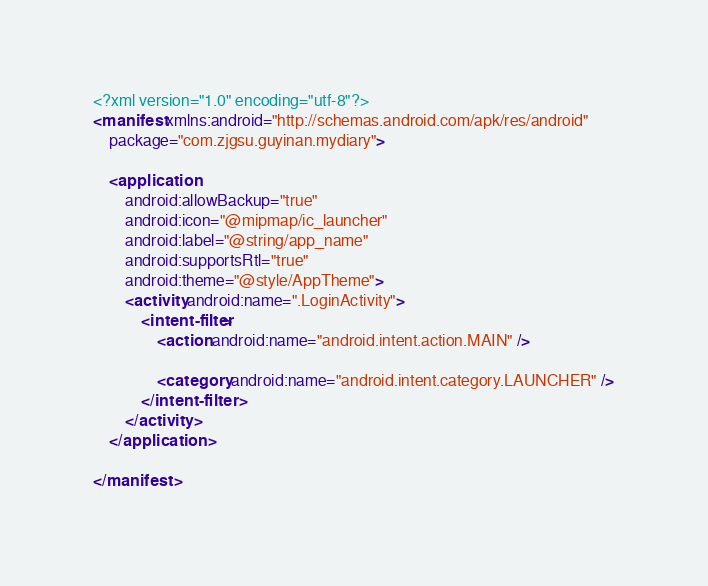<code> <loc_0><loc_0><loc_500><loc_500><_XML_><?xml version="1.0" encoding="utf-8"?>
<manifest xmlns:android="http://schemas.android.com/apk/res/android"
    package="com.zjgsu.guyinan.mydiary">

    <application
        android:allowBackup="true"
        android:icon="@mipmap/ic_launcher"
        android:label="@string/app_name"
        android:supportsRtl="true"
        android:theme="@style/AppTheme">
        <activity android:name=".LoginActivity">
            <intent-filter>
                <action android:name="android.intent.action.MAIN" />

                <category android:name="android.intent.category.LAUNCHER" />
            </intent-filter>
        </activity>
    </application>

</manifest></code> 